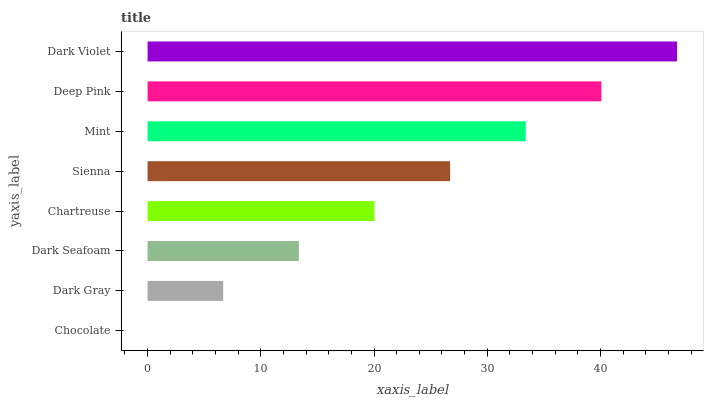Is Chocolate the minimum?
Answer yes or no. Yes. Is Dark Violet the maximum?
Answer yes or no. Yes. Is Dark Gray the minimum?
Answer yes or no. No. Is Dark Gray the maximum?
Answer yes or no. No. Is Dark Gray greater than Chocolate?
Answer yes or no. Yes. Is Chocolate less than Dark Gray?
Answer yes or no. Yes. Is Chocolate greater than Dark Gray?
Answer yes or no. No. Is Dark Gray less than Chocolate?
Answer yes or no. No. Is Sienna the high median?
Answer yes or no. Yes. Is Chartreuse the low median?
Answer yes or no. Yes. Is Dark Seafoam the high median?
Answer yes or no. No. Is Dark Violet the low median?
Answer yes or no. No. 